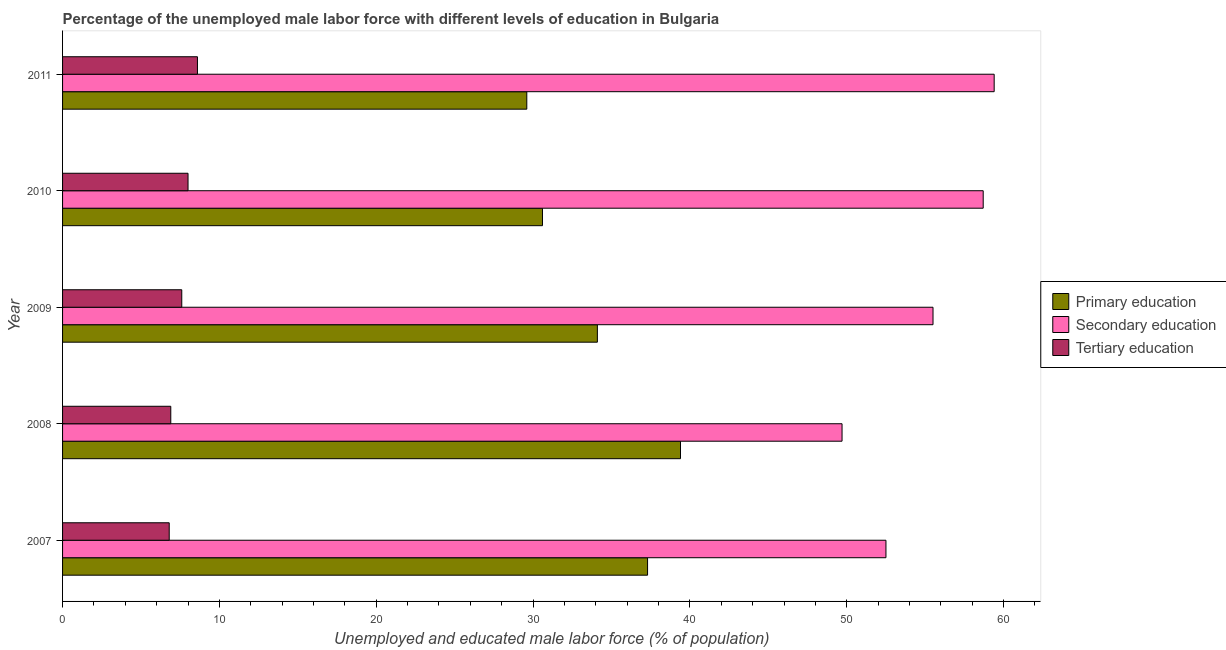Are the number of bars per tick equal to the number of legend labels?
Make the answer very short. Yes. Are the number of bars on each tick of the Y-axis equal?
Offer a terse response. Yes. How many bars are there on the 1st tick from the top?
Your answer should be very brief. 3. What is the percentage of male labor force who received primary education in 2010?
Your response must be concise. 30.6. Across all years, what is the maximum percentage of male labor force who received primary education?
Keep it short and to the point. 39.4. Across all years, what is the minimum percentage of male labor force who received tertiary education?
Provide a succinct answer. 6.8. What is the total percentage of male labor force who received primary education in the graph?
Give a very brief answer. 171. What is the difference between the percentage of male labor force who received tertiary education in 2007 and that in 2011?
Your answer should be compact. -1.8. What is the difference between the percentage of male labor force who received primary education in 2010 and the percentage of male labor force who received tertiary education in 2011?
Your answer should be compact. 22. What is the average percentage of male labor force who received tertiary education per year?
Offer a terse response. 7.58. In the year 2007, what is the difference between the percentage of male labor force who received tertiary education and percentage of male labor force who received secondary education?
Ensure brevity in your answer.  -45.7. What is the ratio of the percentage of male labor force who received tertiary education in 2007 to that in 2009?
Provide a succinct answer. 0.9. In how many years, is the percentage of male labor force who received secondary education greater than the average percentage of male labor force who received secondary education taken over all years?
Ensure brevity in your answer.  3. Is the sum of the percentage of male labor force who received tertiary education in 2007 and 2010 greater than the maximum percentage of male labor force who received primary education across all years?
Ensure brevity in your answer.  No. What does the 2nd bar from the top in 2008 represents?
Provide a succinct answer. Secondary education. What does the 1st bar from the bottom in 2007 represents?
Offer a very short reply. Primary education. How many bars are there?
Make the answer very short. 15. Are all the bars in the graph horizontal?
Keep it short and to the point. Yes. What is the difference between two consecutive major ticks on the X-axis?
Your answer should be compact. 10. Does the graph contain any zero values?
Your answer should be very brief. No. Where does the legend appear in the graph?
Your answer should be very brief. Center right. How many legend labels are there?
Your answer should be very brief. 3. What is the title of the graph?
Offer a very short reply. Percentage of the unemployed male labor force with different levels of education in Bulgaria. What is the label or title of the X-axis?
Offer a very short reply. Unemployed and educated male labor force (% of population). What is the label or title of the Y-axis?
Your answer should be very brief. Year. What is the Unemployed and educated male labor force (% of population) in Primary education in 2007?
Your response must be concise. 37.3. What is the Unemployed and educated male labor force (% of population) in Secondary education in 2007?
Make the answer very short. 52.5. What is the Unemployed and educated male labor force (% of population) in Tertiary education in 2007?
Offer a terse response. 6.8. What is the Unemployed and educated male labor force (% of population) of Primary education in 2008?
Provide a short and direct response. 39.4. What is the Unemployed and educated male labor force (% of population) of Secondary education in 2008?
Offer a very short reply. 49.7. What is the Unemployed and educated male labor force (% of population) of Tertiary education in 2008?
Give a very brief answer. 6.9. What is the Unemployed and educated male labor force (% of population) in Primary education in 2009?
Give a very brief answer. 34.1. What is the Unemployed and educated male labor force (% of population) in Secondary education in 2009?
Give a very brief answer. 55.5. What is the Unemployed and educated male labor force (% of population) of Tertiary education in 2009?
Keep it short and to the point. 7.6. What is the Unemployed and educated male labor force (% of population) of Primary education in 2010?
Provide a short and direct response. 30.6. What is the Unemployed and educated male labor force (% of population) of Secondary education in 2010?
Make the answer very short. 58.7. What is the Unemployed and educated male labor force (% of population) in Primary education in 2011?
Give a very brief answer. 29.6. What is the Unemployed and educated male labor force (% of population) of Secondary education in 2011?
Your response must be concise. 59.4. What is the Unemployed and educated male labor force (% of population) in Tertiary education in 2011?
Provide a short and direct response. 8.6. Across all years, what is the maximum Unemployed and educated male labor force (% of population) of Primary education?
Offer a very short reply. 39.4. Across all years, what is the maximum Unemployed and educated male labor force (% of population) in Secondary education?
Your response must be concise. 59.4. Across all years, what is the maximum Unemployed and educated male labor force (% of population) of Tertiary education?
Your answer should be compact. 8.6. Across all years, what is the minimum Unemployed and educated male labor force (% of population) of Primary education?
Ensure brevity in your answer.  29.6. Across all years, what is the minimum Unemployed and educated male labor force (% of population) in Secondary education?
Make the answer very short. 49.7. Across all years, what is the minimum Unemployed and educated male labor force (% of population) in Tertiary education?
Your answer should be very brief. 6.8. What is the total Unemployed and educated male labor force (% of population) in Primary education in the graph?
Your answer should be very brief. 171. What is the total Unemployed and educated male labor force (% of population) in Secondary education in the graph?
Your answer should be compact. 275.8. What is the total Unemployed and educated male labor force (% of population) in Tertiary education in the graph?
Offer a terse response. 37.9. What is the difference between the Unemployed and educated male labor force (% of population) of Primary education in 2007 and that in 2008?
Provide a short and direct response. -2.1. What is the difference between the Unemployed and educated male labor force (% of population) in Secondary education in 2007 and that in 2008?
Keep it short and to the point. 2.8. What is the difference between the Unemployed and educated male labor force (% of population) of Tertiary education in 2007 and that in 2008?
Make the answer very short. -0.1. What is the difference between the Unemployed and educated male labor force (% of population) of Primary education in 2007 and that in 2009?
Offer a very short reply. 3.2. What is the difference between the Unemployed and educated male labor force (% of population) in Secondary education in 2007 and that in 2010?
Make the answer very short. -6.2. What is the difference between the Unemployed and educated male labor force (% of population) of Secondary education in 2007 and that in 2011?
Keep it short and to the point. -6.9. What is the difference between the Unemployed and educated male labor force (% of population) in Tertiary education in 2007 and that in 2011?
Ensure brevity in your answer.  -1.8. What is the difference between the Unemployed and educated male labor force (% of population) of Primary education in 2008 and that in 2009?
Your response must be concise. 5.3. What is the difference between the Unemployed and educated male labor force (% of population) of Secondary education in 2008 and that in 2009?
Give a very brief answer. -5.8. What is the difference between the Unemployed and educated male labor force (% of population) of Primary education in 2008 and that in 2010?
Provide a short and direct response. 8.8. What is the difference between the Unemployed and educated male labor force (% of population) in Secondary education in 2008 and that in 2011?
Offer a very short reply. -9.7. What is the difference between the Unemployed and educated male labor force (% of population) in Tertiary education in 2008 and that in 2011?
Provide a succinct answer. -1.7. What is the difference between the Unemployed and educated male labor force (% of population) of Tertiary education in 2009 and that in 2010?
Offer a very short reply. -0.4. What is the difference between the Unemployed and educated male labor force (% of population) of Primary education in 2010 and that in 2011?
Your response must be concise. 1. What is the difference between the Unemployed and educated male labor force (% of population) of Tertiary education in 2010 and that in 2011?
Your answer should be very brief. -0.6. What is the difference between the Unemployed and educated male labor force (% of population) of Primary education in 2007 and the Unemployed and educated male labor force (% of population) of Secondary education in 2008?
Your answer should be very brief. -12.4. What is the difference between the Unemployed and educated male labor force (% of population) in Primary education in 2007 and the Unemployed and educated male labor force (% of population) in Tertiary education in 2008?
Offer a terse response. 30.4. What is the difference between the Unemployed and educated male labor force (% of population) of Secondary education in 2007 and the Unemployed and educated male labor force (% of population) of Tertiary education in 2008?
Offer a terse response. 45.6. What is the difference between the Unemployed and educated male labor force (% of population) in Primary education in 2007 and the Unemployed and educated male labor force (% of population) in Secondary education in 2009?
Ensure brevity in your answer.  -18.2. What is the difference between the Unemployed and educated male labor force (% of population) of Primary education in 2007 and the Unemployed and educated male labor force (% of population) of Tertiary education in 2009?
Make the answer very short. 29.7. What is the difference between the Unemployed and educated male labor force (% of population) in Secondary education in 2007 and the Unemployed and educated male labor force (% of population) in Tertiary education in 2009?
Your response must be concise. 44.9. What is the difference between the Unemployed and educated male labor force (% of population) of Primary education in 2007 and the Unemployed and educated male labor force (% of population) of Secondary education in 2010?
Offer a terse response. -21.4. What is the difference between the Unemployed and educated male labor force (% of population) in Primary education in 2007 and the Unemployed and educated male labor force (% of population) in Tertiary education in 2010?
Your answer should be very brief. 29.3. What is the difference between the Unemployed and educated male labor force (% of population) of Secondary education in 2007 and the Unemployed and educated male labor force (% of population) of Tertiary education in 2010?
Keep it short and to the point. 44.5. What is the difference between the Unemployed and educated male labor force (% of population) of Primary education in 2007 and the Unemployed and educated male labor force (% of population) of Secondary education in 2011?
Offer a terse response. -22.1. What is the difference between the Unemployed and educated male labor force (% of population) in Primary education in 2007 and the Unemployed and educated male labor force (% of population) in Tertiary education in 2011?
Keep it short and to the point. 28.7. What is the difference between the Unemployed and educated male labor force (% of population) of Secondary education in 2007 and the Unemployed and educated male labor force (% of population) of Tertiary education in 2011?
Your response must be concise. 43.9. What is the difference between the Unemployed and educated male labor force (% of population) of Primary education in 2008 and the Unemployed and educated male labor force (% of population) of Secondary education in 2009?
Keep it short and to the point. -16.1. What is the difference between the Unemployed and educated male labor force (% of population) in Primary education in 2008 and the Unemployed and educated male labor force (% of population) in Tertiary education in 2009?
Ensure brevity in your answer.  31.8. What is the difference between the Unemployed and educated male labor force (% of population) of Secondary education in 2008 and the Unemployed and educated male labor force (% of population) of Tertiary education in 2009?
Provide a short and direct response. 42.1. What is the difference between the Unemployed and educated male labor force (% of population) in Primary education in 2008 and the Unemployed and educated male labor force (% of population) in Secondary education in 2010?
Offer a terse response. -19.3. What is the difference between the Unemployed and educated male labor force (% of population) in Primary education in 2008 and the Unemployed and educated male labor force (% of population) in Tertiary education in 2010?
Keep it short and to the point. 31.4. What is the difference between the Unemployed and educated male labor force (% of population) in Secondary education in 2008 and the Unemployed and educated male labor force (% of population) in Tertiary education in 2010?
Provide a short and direct response. 41.7. What is the difference between the Unemployed and educated male labor force (% of population) of Primary education in 2008 and the Unemployed and educated male labor force (% of population) of Secondary education in 2011?
Give a very brief answer. -20. What is the difference between the Unemployed and educated male labor force (% of population) of Primary education in 2008 and the Unemployed and educated male labor force (% of population) of Tertiary education in 2011?
Provide a short and direct response. 30.8. What is the difference between the Unemployed and educated male labor force (% of population) of Secondary education in 2008 and the Unemployed and educated male labor force (% of population) of Tertiary education in 2011?
Your answer should be compact. 41.1. What is the difference between the Unemployed and educated male labor force (% of population) of Primary education in 2009 and the Unemployed and educated male labor force (% of population) of Secondary education in 2010?
Your response must be concise. -24.6. What is the difference between the Unemployed and educated male labor force (% of population) of Primary education in 2009 and the Unemployed and educated male labor force (% of population) of Tertiary education in 2010?
Your answer should be compact. 26.1. What is the difference between the Unemployed and educated male labor force (% of population) in Secondary education in 2009 and the Unemployed and educated male labor force (% of population) in Tertiary education in 2010?
Offer a terse response. 47.5. What is the difference between the Unemployed and educated male labor force (% of population) in Primary education in 2009 and the Unemployed and educated male labor force (% of population) in Secondary education in 2011?
Provide a short and direct response. -25.3. What is the difference between the Unemployed and educated male labor force (% of population) of Secondary education in 2009 and the Unemployed and educated male labor force (% of population) of Tertiary education in 2011?
Provide a succinct answer. 46.9. What is the difference between the Unemployed and educated male labor force (% of population) in Primary education in 2010 and the Unemployed and educated male labor force (% of population) in Secondary education in 2011?
Provide a short and direct response. -28.8. What is the difference between the Unemployed and educated male labor force (% of population) in Secondary education in 2010 and the Unemployed and educated male labor force (% of population) in Tertiary education in 2011?
Offer a very short reply. 50.1. What is the average Unemployed and educated male labor force (% of population) of Primary education per year?
Your answer should be very brief. 34.2. What is the average Unemployed and educated male labor force (% of population) in Secondary education per year?
Make the answer very short. 55.16. What is the average Unemployed and educated male labor force (% of population) in Tertiary education per year?
Your answer should be very brief. 7.58. In the year 2007, what is the difference between the Unemployed and educated male labor force (% of population) in Primary education and Unemployed and educated male labor force (% of population) in Secondary education?
Ensure brevity in your answer.  -15.2. In the year 2007, what is the difference between the Unemployed and educated male labor force (% of population) of Primary education and Unemployed and educated male labor force (% of population) of Tertiary education?
Offer a very short reply. 30.5. In the year 2007, what is the difference between the Unemployed and educated male labor force (% of population) of Secondary education and Unemployed and educated male labor force (% of population) of Tertiary education?
Offer a terse response. 45.7. In the year 2008, what is the difference between the Unemployed and educated male labor force (% of population) in Primary education and Unemployed and educated male labor force (% of population) in Tertiary education?
Your answer should be compact. 32.5. In the year 2008, what is the difference between the Unemployed and educated male labor force (% of population) in Secondary education and Unemployed and educated male labor force (% of population) in Tertiary education?
Your response must be concise. 42.8. In the year 2009, what is the difference between the Unemployed and educated male labor force (% of population) of Primary education and Unemployed and educated male labor force (% of population) of Secondary education?
Your answer should be compact. -21.4. In the year 2009, what is the difference between the Unemployed and educated male labor force (% of population) in Secondary education and Unemployed and educated male labor force (% of population) in Tertiary education?
Provide a succinct answer. 47.9. In the year 2010, what is the difference between the Unemployed and educated male labor force (% of population) in Primary education and Unemployed and educated male labor force (% of population) in Secondary education?
Give a very brief answer. -28.1. In the year 2010, what is the difference between the Unemployed and educated male labor force (% of population) in Primary education and Unemployed and educated male labor force (% of population) in Tertiary education?
Provide a short and direct response. 22.6. In the year 2010, what is the difference between the Unemployed and educated male labor force (% of population) of Secondary education and Unemployed and educated male labor force (% of population) of Tertiary education?
Ensure brevity in your answer.  50.7. In the year 2011, what is the difference between the Unemployed and educated male labor force (% of population) in Primary education and Unemployed and educated male labor force (% of population) in Secondary education?
Offer a terse response. -29.8. In the year 2011, what is the difference between the Unemployed and educated male labor force (% of population) in Primary education and Unemployed and educated male labor force (% of population) in Tertiary education?
Your response must be concise. 21. In the year 2011, what is the difference between the Unemployed and educated male labor force (% of population) in Secondary education and Unemployed and educated male labor force (% of population) in Tertiary education?
Your answer should be compact. 50.8. What is the ratio of the Unemployed and educated male labor force (% of population) of Primary education in 2007 to that in 2008?
Offer a terse response. 0.95. What is the ratio of the Unemployed and educated male labor force (% of population) in Secondary education in 2007 to that in 2008?
Ensure brevity in your answer.  1.06. What is the ratio of the Unemployed and educated male labor force (% of population) of Tertiary education in 2007 to that in 2008?
Make the answer very short. 0.99. What is the ratio of the Unemployed and educated male labor force (% of population) of Primary education in 2007 to that in 2009?
Your response must be concise. 1.09. What is the ratio of the Unemployed and educated male labor force (% of population) in Secondary education in 2007 to that in 2009?
Offer a terse response. 0.95. What is the ratio of the Unemployed and educated male labor force (% of population) in Tertiary education in 2007 to that in 2009?
Offer a terse response. 0.89. What is the ratio of the Unemployed and educated male labor force (% of population) in Primary education in 2007 to that in 2010?
Offer a very short reply. 1.22. What is the ratio of the Unemployed and educated male labor force (% of population) in Secondary education in 2007 to that in 2010?
Your response must be concise. 0.89. What is the ratio of the Unemployed and educated male labor force (% of population) of Tertiary education in 2007 to that in 2010?
Offer a terse response. 0.85. What is the ratio of the Unemployed and educated male labor force (% of population) in Primary education in 2007 to that in 2011?
Provide a short and direct response. 1.26. What is the ratio of the Unemployed and educated male labor force (% of population) in Secondary education in 2007 to that in 2011?
Your response must be concise. 0.88. What is the ratio of the Unemployed and educated male labor force (% of population) in Tertiary education in 2007 to that in 2011?
Offer a very short reply. 0.79. What is the ratio of the Unemployed and educated male labor force (% of population) in Primary education in 2008 to that in 2009?
Offer a very short reply. 1.16. What is the ratio of the Unemployed and educated male labor force (% of population) in Secondary education in 2008 to that in 2009?
Ensure brevity in your answer.  0.9. What is the ratio of the Unemployed and educated male labor force (% of population) of Tertiary education in 2008 to that in 2009?
Your response must be concise. 0.91. What is the ratio of the Unemployed and educated male labor force (% of population) of Primary education in 2008 to that in 2010?
Offer a terse response. 1.29. What is the ratio of the Unemployed and educated male labor force (% of population) in Secondary education in 2008 to that in 2010?
Offer a very short reply. 0.85. What is the ratio of the Unemployed and educated male labor force (% of population) in Tertiary education in 2008 to that in 2010?
Make the answer very short. 0.86. What is the ratio of the Unemployed and educated male labor force (% of population) of Primary education in 2008 to that in 2011?
Provide a short and direct response. 1.33. What is the ratio of the Unemployed and educated male labor force (% of population) of Secondary education in 2008 to that in 2011?
Keep it short and to the point. 0.84. What is the ratio of the Unemployed and educated male labor force (% of population) of Tertiary education in 2008 to that in 2011?
Keep it short and to the point. 0.8. What is the ratio of the Unemployed and educated male labor force (% of population) in Primary education in 2009 to that in 2010?
Ensure brevity in your answer.  1.11. What is the ratio of the Unemployed and educated male labor force (% of population) of Secondary education in 2009 to that in 2010?
Ensure brevity in your answer.  0.95. What is the ratio of the Unemployed and educated male labor force (% of population) of Tertiary education in 2009 to that in 2010?
Your response must be concise. 0.95. What is the ratio of the Unemployed and educated male labor force (% of population) in Primary education in 2009 to that in 2011?
Keep it short and to the point. 1.15. What is the ratio of the Unemployed and educated male labor force (% of population) in Secondary education in 2009 to that in 2011?
Keep it short and to the point. 0.93. What is the ratio of the Unemployed and educated male labor force (% of population) of Tertiary education in 2009 to that in 2011?
Your answer should be compact. 0.88. What is the ratio of the Unemployed and educated male labor force (% of population) of Primary education in 2010 to that in 2011?
Your answer should be very brief. 1.03. What is the ratio of the Unemployed and educated male labor force (% of population) of Secondary education in 2010 to that in 2011?
Your answer should be very brief. 0.99. What is the ratio of the Unemployed and educated male labor force (% of population) of Tertiary education in 2010 to that in 2011?
Ensure brevity in your answer.  0.93. What is the difference between the highest and the lowest Unemployed and educated male labor force (% of population) in Secondary education?
Offer a very short reply. 9.7. What is the difference between the highest and the lowest Unemployed and educated male labor force (% of population) of Tertiary education?
Offer a very short reply. 1.8. 